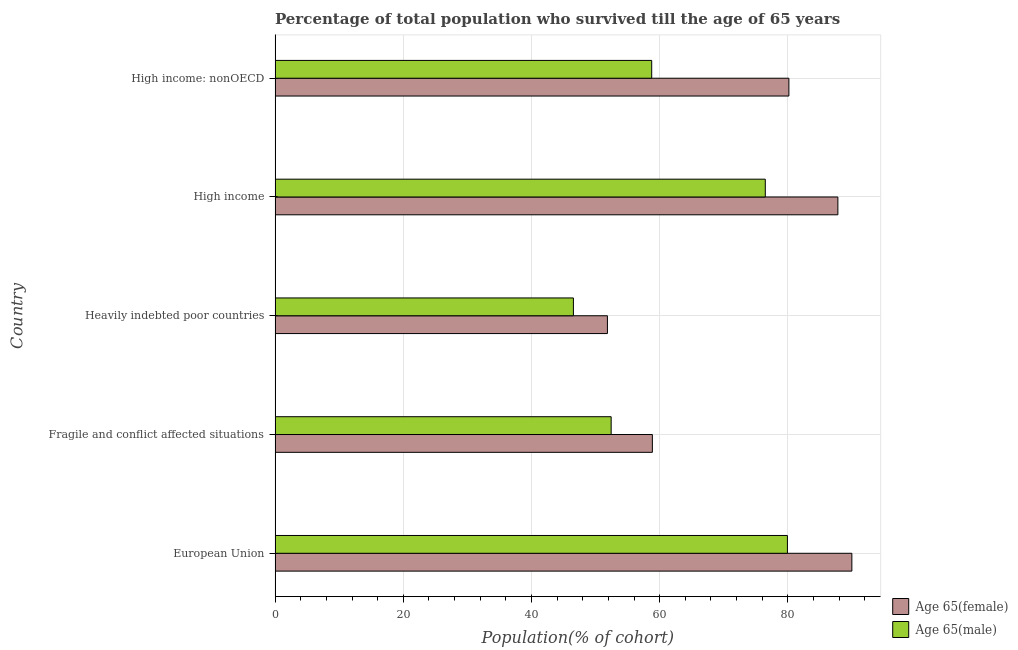How many groups of bars are there?
Provide a short and direct response. 5. Are the number of bars on each tick of the Y-axis equal?
Keep it short and to the point. Yes. In how many cases, is the number of bars for a given country not equal to the number of legend labels?
Your answer should be compact. 0. What is the percentage of male population who survived till age of 65 in Fragile and conflict affected situations?
Offer a terse response. 52.44. Across all countries, what is the maximum percentage of male population who survived till age of 65?
Your response must be concise. 79.94. Across all countries, what is the minimum percentage of female population who survived till age of 65?
Your response must be concise. 51.85. In which country was the percentage of female population who survived till age of 65 minimum?
Your response must be concise. Heavily indebted poor countries. What is the total percentage of male population who survived till age of 65 in the graph?
Your response must be concise. 314.16. What is the difference between the percentage of male population who survived till age of 65 in High income and the percentage of female population who survived till age of 65 in High income: nonOECD?
Provide a succinct answer. -3.68. What is the average percentage of female population who survived till age of 65 per country?
Offer a very short reply. 73.73. What is the difference between the percentage of male population who survived till age of 65 and percentage of female population who survived till age of 65 in Heavily indebted poor countries?
Offer a terse response. -5.31. What is the ratio of the percentage of female population who survived till age of 65 in European Union to that in Heavily indebted poor countries?
Keep it short and to the point. 1.74. Is the percentage of female population who survived till age of 65 in European Union less than that in High income?
Provide a short and direct response. No. What is the difference between the highest and the second highest percentage of female population who survived till age of 65?
Your response must be concise. 2.18. What is the difference between the highest and the lowest percentage of male population who survived till age of 65?
Offer a terse response. 33.39. In how many countries, is the percentage of female population who survived till age of 65 greater than the average percentage of female population who survived till age of 65 taken over all countries?
Offer a terse response. 3. What does the 1st bar from the top in Heavily indebted poor countries represents?
Provide a short and direct response. Age 65(male). What does the 1st bar from the bottom in Heavily indebted poor countries represents?
Your response must be concise. Age 65(female). Are all the bars in the graph horizontal?
Your answer should be very brief. Yes. What is the difference between two consecutive major ticks on the X-axis?
Make the answer very short. 20. Does the graph contain grids?
Your answer should be compact. Yes. Where does the legend appear in the graph?
Ensure brevity in your answer.  Bottom right. What is the title of the graph?
Keep it short and to the point. Percentage of total population who survived till the age of 65 years. Does "Netherlands" appear as one of the legend labels in the graph?
Provide a succinct answer. No. What is the label or title of the X-axis?
Offer a very short reply. Population(% of cohort). What is the Population(% of cohort) of Age 65(female) in European Union?
Provide a short and direct response. 89.99. What is the Population(% of cohort) in Age 65(male) in European Union?
Give a very brief answer. 79.94. What is the Population(% of cohort) in Age 65(female) in Fragile and conflict affected situations?
Provide a succinct answer. 58.86. What is the Population(% of cohort) of Age 65(male) in Fragile and conflict affected situations?
Offer a terse response. 52.44. What is the Population(% of cohort) in Age 65(female) in Heavily indebted poor countries?
Your response must be concise. 51.85. What is the Population(% of cohort) of Age 65(male) in Heavily indebted poor countries?
Offer a very short reply. 46.54. What is the Population(% of cohort) in Age 65(female) in High income?
Provide a succinct answer. 87.81. What is the Population(% of cohort) of Age 65(male) in High income?
Provide a succinct answer. 76.48. What is the Population(% of cohort) in Age 65(female) in High income: nonOECD?
Ensure brevity in your answer.  80.16. What is the Population(% of cohort) in Age 65(male) in High income: nonOECD?
Make the answer very short. 58.76. Across all countries, what is the maximum Population(% of cohort) in Age 65(female)?
Ensure brevity in your answer.  89.99. Across all countries, what is the maximum Population(% of cohort) in Age 65(male)?
Keep it short and to the point. 79.94. Across all countries, what is the minimum Population(% of cohort) of Age 65(female)?
Your answer should be very brief. 51.85. Across all countries, what is the minimum Population(% of cohort) in Age 65(male)?
Ensure brevity in your answer.  46.54. What is the total Population(% of cohort) in Age 65(female) in the graph?
Ensure brevity in your answer.  368.67. What is the total Population(% of cohort) of Age 65(male) in the graph?
Your answer should be compact. 314.16. What is the difference between the Population(% of cohort) of Age 65(female) in European Union and that in Fragile and conflict affected situations?
Ensure brevity in your answer.  31.13. What is the difference between the Population(% of cohort) of Age 65(male) in European Union and that in Fragile and conflict affected situations?
Offer a terse response. 27.5. What is the difference between the Population(% of cohort) in Age 65(female) in European Union and that in Heavily indebted poor countries?
Make the answer very short. 38.14. What is the difference between the Population(% of cohort) of Age 65(male) in European Union and that in Heavily indebted poor countries?
Provide a short and direct response. 33.39. What is the difference between the Population(% of cohort) of Age 65(female) in European Union and that in High income?
Make the answer very short. 2.18. What is the difference between the Population(% of cohort) of Age 65(male) in European Union and that in High income?
Offer a very short reply. 3.45. What is the difference between the Population(% of cohort) of Age 65(female) in European Union and that in High income: nonOECD?
Ensure brevity in your answer.  9.82. What is the difference between the Population(% of cohort) of Age 65(male) in European Union and that in High income: nonOECD?
Offer a terse response. 21.17. What is the difference between the Population(% of cohort) of Age 65(female) in Fragile and conflict affected situations and that in Heavily indebted poor countries?
Give a very brief answer. 7.01. What is the difference between the Population(% of cohort) of Age 65(male) in Fragile and conflict affected situations and that in Heavily indebted poor countries?
Provide a succinct answer. 5.89. What is the difference between the Population(% of cohort) in Age 65(female) in Fragile and conflict affected situations and that in High income?
Your answer should be compact. -28.94. What is the difference between the Population(% of cohort) of Age 65(male) in Fragile and conflict affected situations and that in High income?
Provide a succinct answer. -24.05. What is the difference between the Population(% of cohort) of Age 65(female) in Fragile and conflict affected situations and that in High income: nonOECD?
Offer a very short reply. -21.3. What is the difference between the Population(% of cohort) of Age 65(male) in Fragile and conflict affected situations and that in High income: nonOECD?
Provide a succinct answer. -6.33. What is the difference between the Population(% of cohort) of Age 65(female) in Heavily indebted poor countries and that in High income?
Offer a terse response. -35.96. What is the difference between the Population(% of cohort) in Age 65(male) in Heavily indebted poor countries and that in High income?
Your answer should be very brief. -29.94. What is the difference between the Population(% of cohort) of Age 65(female) in Heavily indebted poor countries and that in High income: nonOECD?
Give a very brief answer. -28.31. What is the difference between the Population(% of cohort) in Age 65(male) in Heavily indebted poor countries and that in High income: nonOECD?
Your response must be concise. -12.22. What is the difference between the Population(% of cohort) of Age 65(female) in High income and that in High income: nonOECD?
Ensure brevity in your answer.  7.64. What is the difference between the Population(% of cohort) in Age 65(male) in High income and that in High income: nonOECD?
Keep it short and to the point. 17.72. What is the difference between the Population(% of cohort) of Age 65(female) in European Union and the Population(% of cohort) of Age 65(male) in Fragile and conflict affected situations?
Provide a short and direct response. 37.55. What is the difference between the Population(% of cohort) of Age 65(female) in European Union and the Population(% of cohort) of Age 65(male) in Heavily indebted poor countries?
Keep it short and to the point. 43.44. What is the difference between the Population(% of cohort) of Age 65(female) in European Union and the Population(% of cohort) of Age 65(male) in High income?
Offer a very short reply. 13.51. What is the difference between the Population(% of cohort) of Age 65(female) in European Union and the Population(% of cohort) of Age 65(male) in High income: nonOECD?
Offer a terse response. 31.23. What is the difference between the Population(% of cohort) of Age 65(female) in Fragile and conflict affected situations and the Population(% of cohort) of Age 65(male) in Heavily indebted poor countries?
Keep it short and to the point. 12.32. What is the difference between the Population(% of cohort) of Age 65(female) in Fragile and conflict affected situations and the Population(% of cohort) of Age 65(male) in High income?
Give a very brief answer. -17.62. What is the difference between the Population(% of cohort) in Age 65(female) in Fragile and conflict affected situations and the Population(% of cohort) in Age 65(male) in High income: nonOECD?
Offer a terse response. 0.1. What is the difference between the Population(% of cohort) of Age 65(female) in Heavily indebted poor countries and the Population(% of cohort) of Age 65(male) in High income?
Offer a very short reply. -24.63. What is the difference between the Population(% of cohort) in Age 65(female) in Heavily indebted poor countries and the Population(% of cohort) in Age 65(male) in High income: nonOECD?
Provide a short and direct response. -6.91. What is the difference between the Population(% of cohort) in Age 65(female) in High income and the Population(% of cohort) in Age 65(male) in High income: nonOECD?
Your response must be concise. 29.05. What is the average Population(% of cohort) of Age 65(female) per country?
Keep it short and to the point. 73.73. What is the average Population(% of cohort) of Age 65(male) per country?
Offer a terse response. 62.83. What is the difference between the Population(% of cohort) of Age 65(female) and Population(% of cohort) of Age 65(male) in European Union?
Ensure brevity in your answer.  10.05. What is the difference between the Population(% of cohort) in Age 65(female) and Population(% of cohort) in Age 65(male) in Fragile and conflict affected situations?
Give a very brief answer. 6.43. What is the difference between the Population(% of cohort) of Age 65(female) and Population(% of cohort) of Age 65(male) in Heavily indebted poor countries?
Ensure brevity in your answer.  5.31. What is the difference between the Population(% of cohort) in Age 65(female) and Population(% of cohort) in Age 65(male) in High income?
Give a very brief answer. 11.32. What is the difference between the Population(% of cohort) in Age 65(female) and Population(% of cohort) in Age 65(male) in High income: nonOECD?
Ensure brevity in your answer.  21.4. What is the ratio of the Population(% of cohort) in Age 65(female) in European Union to that in Fragile and conflict affected situations?
Offer a very short reply. 1.53. What is the ratio of the Population(% of cohort) of Age 65(male) in European Union to that in Fragile and conflict affected situations?
Make the answer very short. 1.52. What is the ratio of the Population(% of cohort) of Age 65(female) in European Union to that in Heavily indebted poor countries?
Your response must be concise. 1.74. What is the ratio of the Population(% of cohort) of Age 65(male) in European Union to that in Heavily indebted poor countries?
Keep it short and to the point. 1.72. What is the ratio of the Population(% of cohort) in Age 65(female) in European Union to that in High income?
Offer a terse response. 1.02. What is the ratio of the Population(% of cohort) of Age 65(male) in European Union to that in High income?
Provide a succinct answer. 1.05. What is the ratio of the Population(% of cohort) of Age 65(female) in European Union to that in High income: nonOECD?
Make the answer very short. 1.12. What is the ratio of the Population(% of cohort) of Age 65(male) in European Union to that in High income: nonOECD?
Offer a terse response. 1.36. What is the ratio of the Population(% of cohort) of Age 65(female) in Fragile and conflict affected situations to that in Heavily indebted poor countries?
Your answer should be compact. 1.14. What is the ratio of the Population(% of cohort) of Age 65(male) in Fragile and conflict affected situations to that in Heavily indebted poor countries?
Provide a short and direct response. 1.13. What is the ratio of the Population(% of cohort) in Age 65(female) in Fragile and conflict affected situations to that in High income?
Your response must be concise. 0.67. What is the ratio of the Population(% of cohort) of Age 65(male) in Fragile and conflict affected situations to that in High income?
Your answer should be compact. 0.69. What is the ratio of the Population(% of cohort) in Age 65(female) in Fragile and conflict affected situations to that in High income: nonOECD?
Provide a succinct answer. 0.73. What is the ratio of the Population(% of cohort) of Age 65(male) in Fragile and conflict affected situations to that in High income: nonOECD?
Offer a terse response. 0.89. What is the ratio of the Population(% of cohort) in Age 65(female) in Heavily indebted poor countries to that in High income?
Your answer should be compact. 0.59. What is the ratio of the Population(% of cohort) of Age 65(male) in Heavily indebted poor countries to that in High income?
Make the answer very short. 0.61. What is the ratio of the Population(% of cohort) in Age 65(female) in Heavily indebted poor countries to that in High income: nonOECD?
Provide a short and direct response. 0.65. What is the ratio of the Population(% of cohort) in Age 65(male) in Heavily indebted poor countries to that in High income: nonOECD?
Ensure brevity in your answer.  0.79. What is the ratio of the Population(% of cohort) of Age 65(female) in High income to that in High income: nonOECD?
Ensure brevity in your answer.  1.1. What is the ratio of the Population(% of cohort) of Age 65(male) in High income to that in High income: nonOECD?
Offer a very short reply. 1.3. What is the difference between the highest and the second highest Population(% of cohort) in Age 65(female)?
Provide a succinct answer. 2.18. What is the difference between the highest and the second highest Population(% of cohort) in Age 65(male)?
Your answer should be compact. 3.45. What is the difference between the highest and the lowest Population(% of cohort) of Age 65(female)?
Provide a short and direct response. 38.14. What is the difference between the highest and the lowest Population(% of cohort) of Age 65(male)?
Keep it short and to the point. 33.39. 